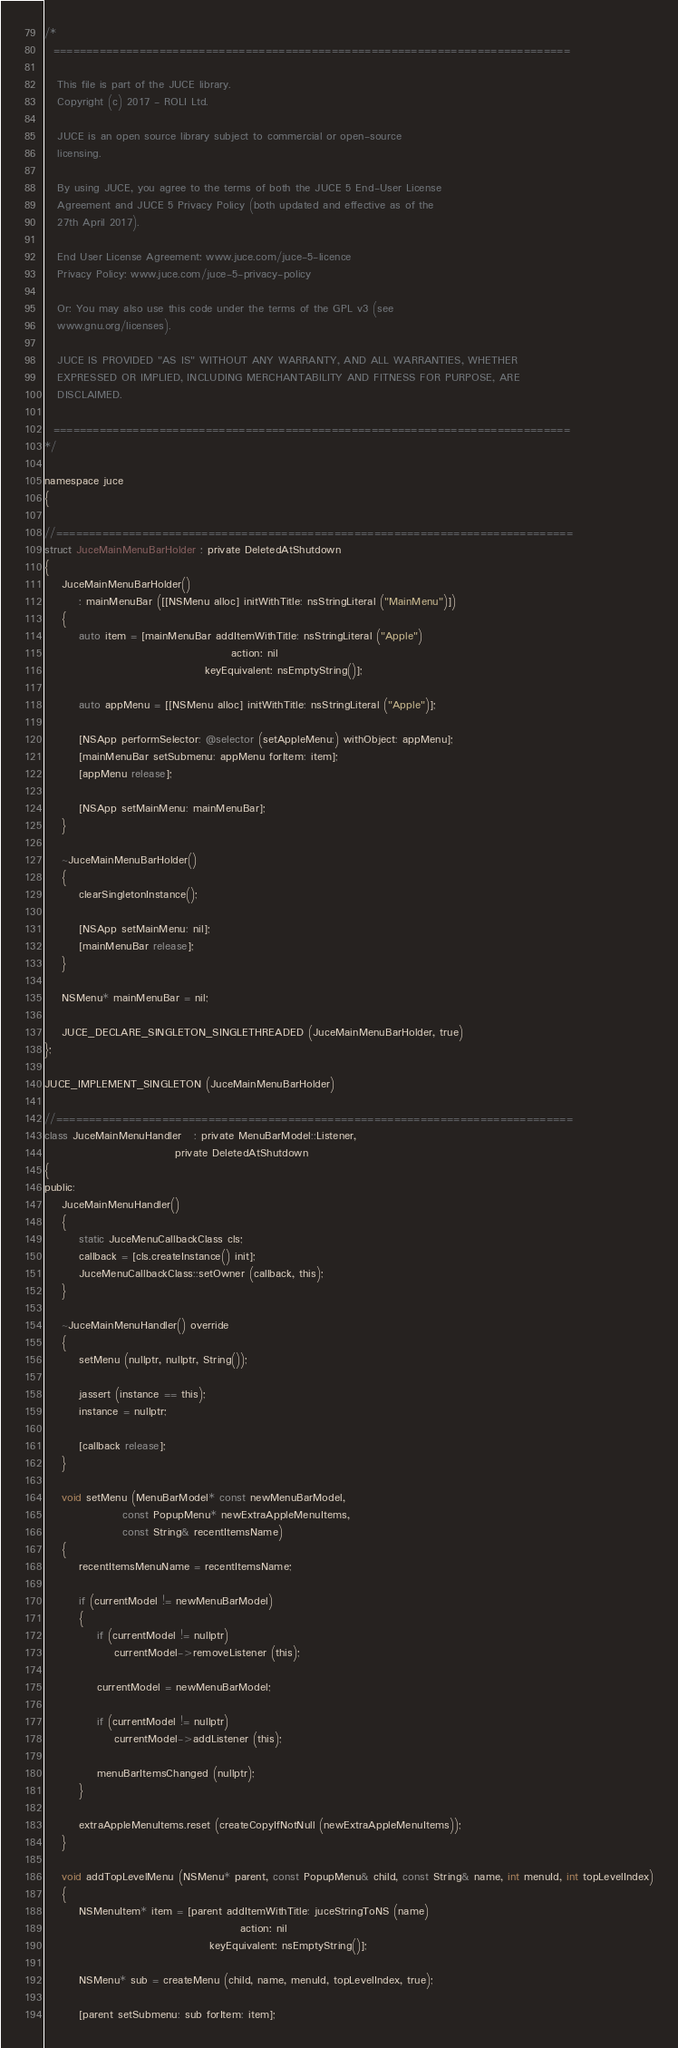Convert code to text. <code><loc_0><loc_0><loc_500><loc_500><_ObjectiveC_>/*
  ==============================================================================

   This file is part of the JUCE library.
   Copyright (c) 2017 - ROLI Ltd.

   JUCE is an open source library subject to commercial or open-source
   licensing.

   By using JUCE, you agree to the terms of both the JUCE 5 End-User License
   Agreement and JUCE 5 Privacy Policy (both updated and effective as of the
   27th April 2017).

   End User License Agreement: www.juce.com/juce-5-licence
   Privacy Policy: www.juce.com/juce-5-privacy-policy

   Or: You may also use this code under the terms of the GPL v3 (see
   www.gnu.org/licenses).

   JUCE IS PROVIDED "AS IS" WITHOUT ANY WARRANTY, AND ALL WARRANTIES, WHETHER
   EXPRESSED OR IMPLIED, INCLUDING MERCHANTABILITY AND FITNESS FOR PURPOSE, ARE
   DISCLAIMED.

  ==============================================================================
*/

namespace juce
{

//==============================================================================
struct JuceMainMenuBarHolder : private DeletedAtShutdown
{
    JuceMainMenuBarHolder()
        : mainMenuBar ([[NSMenu alloc] initWithTitle: nsStringLiteral ("MainMenu")])
    {
        auto item = [mainMenuBar addItemWithTitle: nsStringLiteral ("Apple")
                                           action: nil
                                     keyEquivalent: nsEmptyString()];

        auto appMenu = [[NSMenu alloc] initWithTitle: nsStringLiteral ("Apple")];

        [NSApp performSelector: @selector (setAppleMenu:) withObject: appMenu];
        [mainMenuBar setSubmenu: appMenu forItem: item];
        [appMenu release];

        [NSApp setMainMenu: mainMenuBar];
    }

    ~JuceMainMenuBarHolder()
    {
        clearSingletonInstance();

        [NSApp setMainMenu: nil];
        [mainMenuBar release];
    }

    NSMenu* mainMenuBar = nil;

    JUCE_DECLARE_SINGLETON_SINGLETHREADED (JuceMainMenuBarHolder, true)
};

JUCE_IMPLEMENT_SINGLETON (JuceMainMenuBarHolder)

//==============================================================================
class JuceMainMenuHandler   : private MenuBarModel::Listener,
                              private DeletedAtShutdown
{
public:
    JuceMainMenuHandler()
    {
        static JuceMenuCallbackClass cls;
        callback = [cls.createInstance() init];
        JuceMenuCallbackClass::setOwner (callback, this);
    }

    ~JuceMainMenuHandler() override
    {
        setMenu (nullptr, nullptr, String());

        jassert (instance == this);
        instance = nullptr;

        [callback release];
    }

    void setMenu (MenuBarModel* const newMenuBarModel,
                  const PopupMenu* newExtraAppleMenuItems,
                  const String& recentItemsName)
    {
        recentItemsMenuName = recentItemsName;

        if (currentModel != newMenuBarModel)
        {
            if (currentModel != nullptr)
                currentModel->removeListener (this);

            currentModel = newMenuBarModel;

            if (currentModel != nullptr)
                currentModel->addListener (this);

            menuBarItemsChanged (nullptr);
        }

        extraAppleMenuItems.reset (createCopyIfNotNull (newExtraAppleMenuItems));
    }

    void addTopLevelMenu (NSMenu* parent, const PopupMenu& child, const String& name, int menuId, int topLevelIndex)
    {
        NSMenuItem* item = [parent addItemWithTitle: juceStringToNS (name)
                                             action: nil
                                      keyEquivalent: nsEmptyString()];

        NSMenu* sub = createMenu (child, name, menuId, topLevelIndex, true);

        [parent setSubmenu: sub forItem: item];</code> 